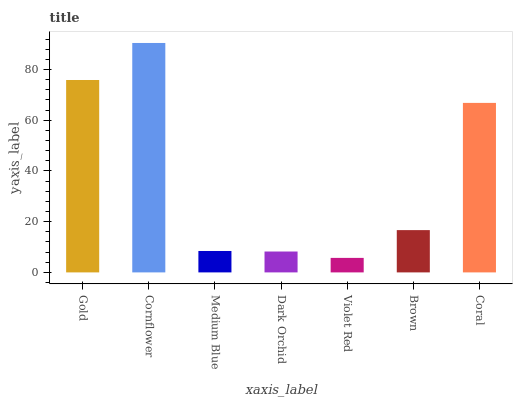Is Violet Red the minimum?
Answer yes or no. Yes. Is Cornflower the maximum?
Answer yes or no. Yes. Is Medium Blue the minimum?
Answer yes or no. No. Is Medium Blue the maximum?
Answer yes or no. No. Is Cornflower greater than Medium Blue?
Answer yes or no. Yes. Is Medium Blue less than Cornflower?
Answer yes or no. Yes. Is Medium Blue greater than Cornflower?
Answer yes or no. No. Is Cornflower less than Medium Blue?
Answer yes or no. No. Is Brown the high median?
Answer yes or no. Yes. Is Brown the low median?
Answer yes or no. Yes. Is Cornflower the high median?
Answer yes or no. No. Is Medium Blue the low median?
Answer yes or no. No. 